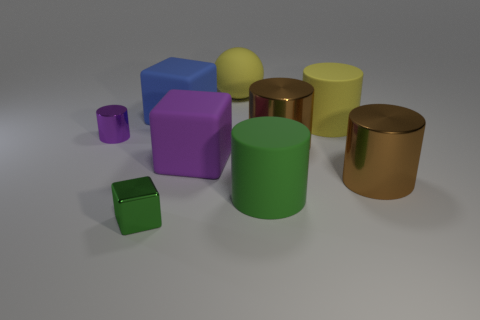What is the shape of the object that is the same color as the tiny block? The object sharing the same color as the tiny block has a cylindrical shape. It's one of the larger objects in the image, with a smooth curved surface and circular base, reflecting light and showing a glossy finish. 